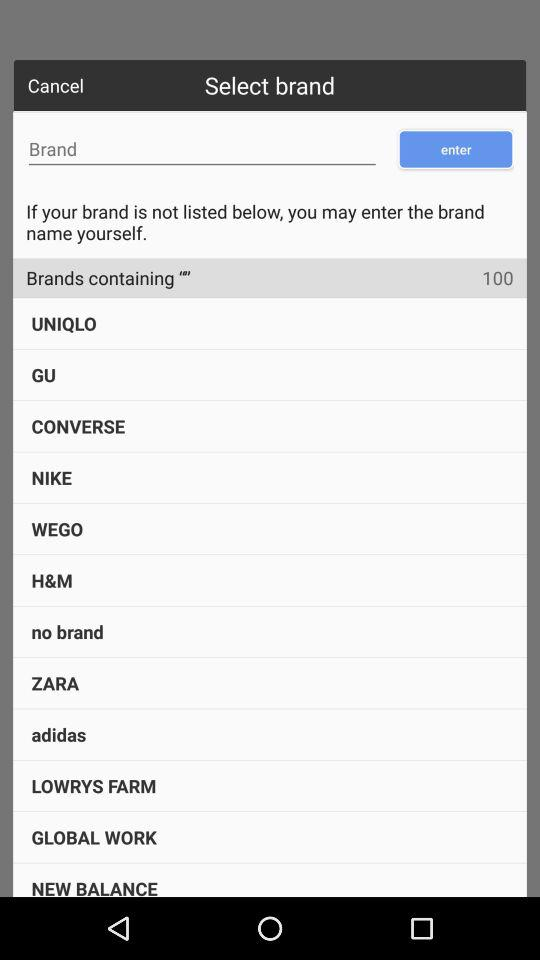What is the number of brands? The number of brands is 100. 